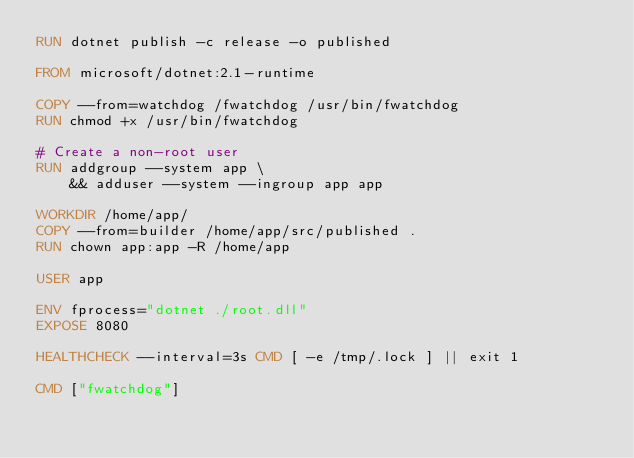<code> <loc_0><loc_0><loc_500><loc_500><_Dockerfile_>RUN dotnet publish -c release -o published

FROM microsoft/dotnet:2.1-runtime

COPY --from=watchdog /fwatchdog /usr/bin/fwatchdog
RUN chmod +x /usr/bin/fwatchdog

# Create a non-root user
RUN addgroup --system app \
    && adduser --system --ingroup app app

WORKDIR /home/app/
COPY --from=builder /home/app/src/published .
RUN chown app:app -R /home/app

USER app

ENV fprocess="dotnet ./root.dll"
EXPOSE 8080

HEALTHCHECK --interval=3s CMD [ -e /tmp/.lock ] || exit 1

CMD ["fwatchdog"]
</code> 